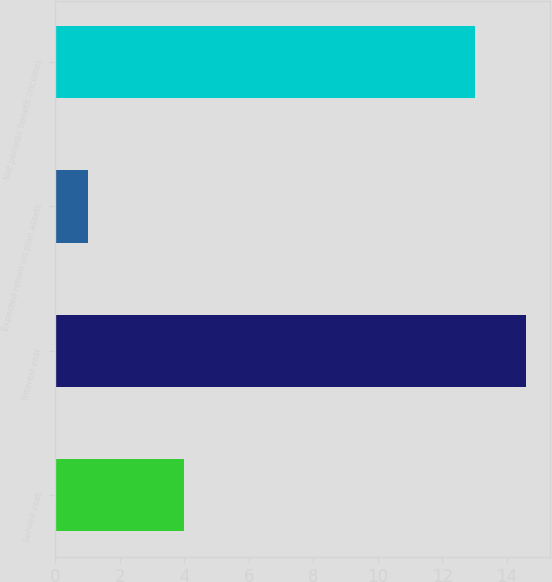Convert chart. <chart><loc_0><loc_0><loc_500><loc_500><bar_chart><fcel>Service cost<fcel>Interest cost<fcel>Expected return on plan assets<fcel>Net periodic benefit (income)<nl><fcel>4<fcel>14.6<fcel>1<fcel>13<nl></chart> 